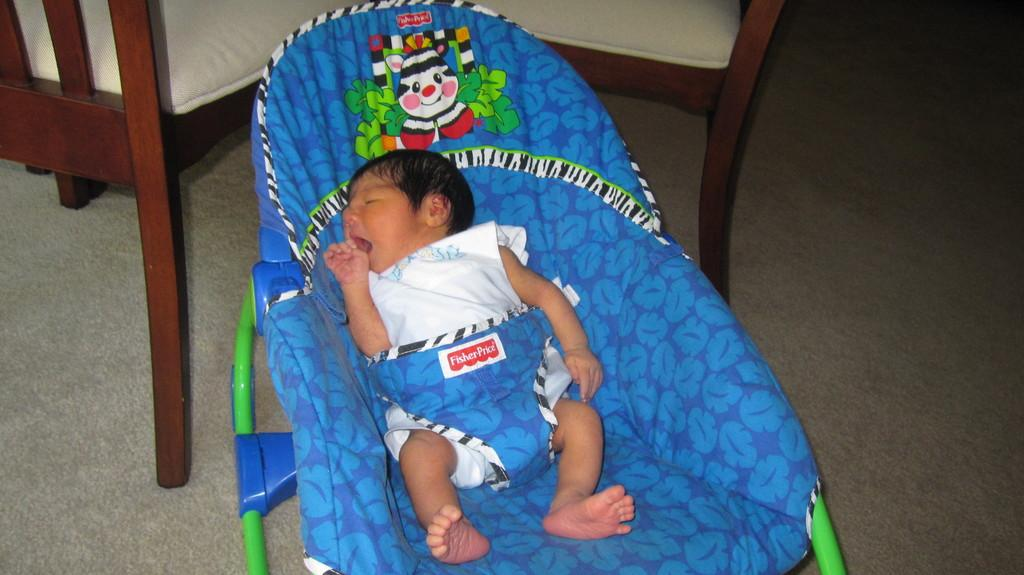What is the baby doing in the image? The baby is sleeping. What type of flooring is visible in the image? There is a carpet in the image. What type of furniture can be seen in the image? There are chairs in the image. What month is the bear wearing in the image? There is no bear present in the image, and therefore no clothing or month can be observed. 